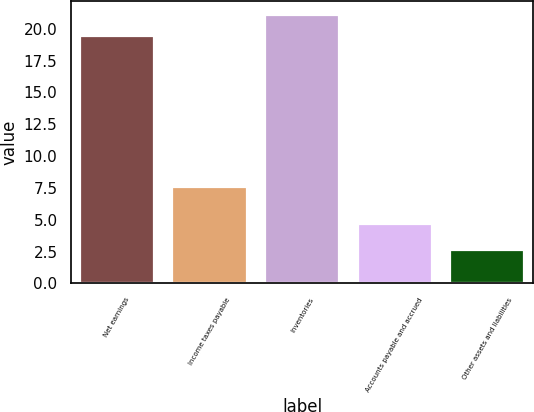<chart> <loc_0><loc_0><loc_500><loc_500><bar_chart><fcel>Net earnings<fcel>Income taxes payable<fcel>Inventories<fcel>Accounts payable and accrued<fcel>Other assets and liabilities<nl><fcel>19.4<fcel>7.6<fcel>21.11<fcel>4.7<fcel>2.6<nl></chart> 